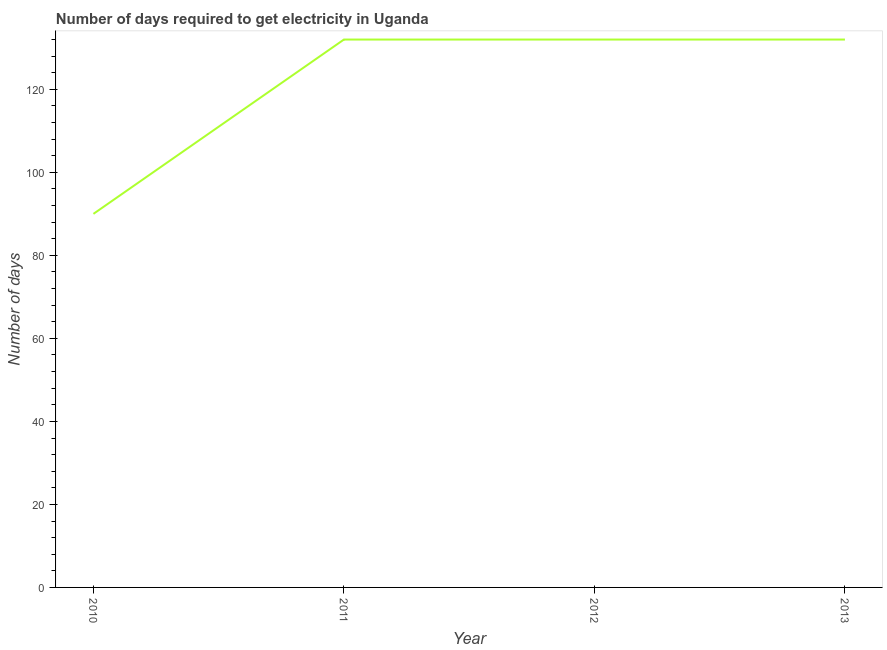What is the time to get electricity in 2010?
Your answer should be very brief. 90. Across all years, what is the maximum time to get electricity?
Keep it short and to the point. 132. Across all years, what is the minimum time to get electricity?
Offer a very short reply. 90. In which year was the time to get electricity maximum?
Provide a succinct answer. 2011. What is the sum of the time to get electricity?
Keep it short and to the point. 486. What is the average time to get electricity per year?
Provide a succinct answer. 121.5. What is the median time to get electricity?
Make the answer very short. 132. In how many years, is the time to get electricity greater than 116 ?
Offer a very short reply. 3. What is the ratio of the time to get electricity in 2010 to that in 2012?
Give a very brief answer. 0.68. Is the time to get electricity in 2011 less than that in 2012?
Provide a succinct answer. No. Is the difference between the time to get electricity in 2012 and 2013 greater than the difference between any two years?
Provide a short and direct response. No. What is the difference between the highest and the lowest time to get electricity?
Provide a short and direct response. 42. How many lines are there?
Your response must be concise. 1. How many years are there in the graph?
Offer a terse response. 4. Are the values on the major ticks of Y-axis written in scientific E-notation?
Offer a terse response. No. Does the graph contain grids?
Provide a short and direct response. No. What is the title of the graph?
Provide a succinct answer. Number of days required to get electricity in Uganda. What is the label or title of the X-axis?
Offer a terse response. Year. What is the label or title of the Y-axis?
Offer a terse response. Number of days. What is the Number of days in 2010?
Offer a very short reply. 90. What is the Number of days of 2011?
Provide a short and direct response. 132. What is the Number of days of 2012?
Offer a terse response. 132. What is the Number of days in 2013?
Your response must be concise. 132. What is the difference between the Number of days in 2010 and 2011?
Give a very brief answer. -42. What is the difference between the Number of days in 2010 and 2012?
Provide a short and direct response. -42. What is the difference between the Number of days in 2010 and 2013?
Offer a terse response. -42. What is the difference between the Number of days in 2011 and 2013?
Offer a terse response. 0. What is the difference between the Number of days in 2012 and 2013?
Offer a very short reply. 0. What is the ratio of the Number of days in 2010 to that in 2011?
Give a very brief answer. 0.68. What is the ratio of the Number of days in 2010 to that in 2012?
Your answer should be compact. 0.68. What is the ratio of the Number of days in 2010 to that in 2013?
Your response must be concise. 0.68. What is the ratio of the Number of days in 2011 to that in 2013?
Provide a short and direct response. 1. 